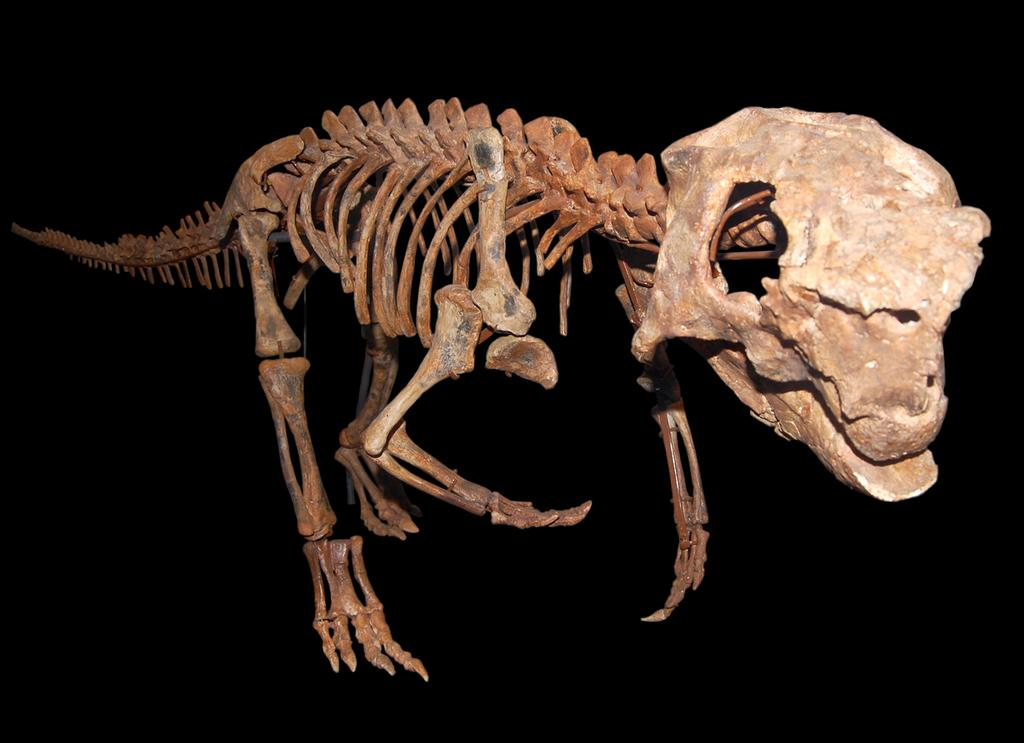What is the main subject of the image? The main subject of the image is a skeleton of an animal. What can be said about the color of the skeleton? The skeleton is brown in color. What is the color of the background in the image? The background of the image is black. What type of wrench is being used to assemble the skeleton in the image? There is no wrench present in the image, and the skeleton is not being assembled. 